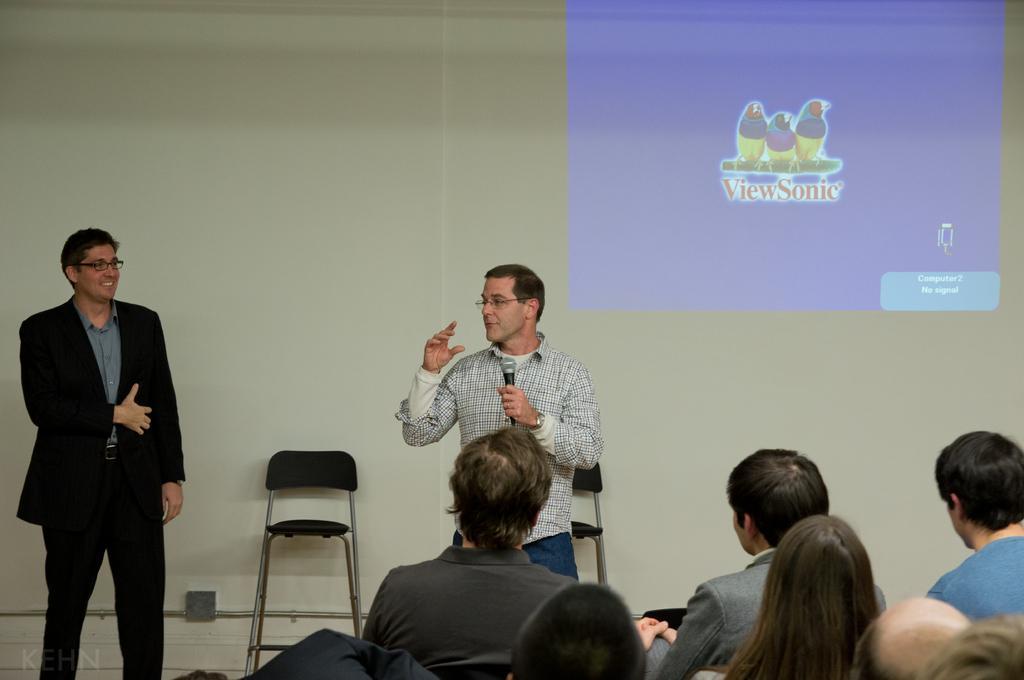Could you give a brief overview of what you see in this image? In a room there are lot of crowd sitting and chairs and listening to man speaking on microphone. Behind him there are few chairs and beside the chair there is another man standing in black blazer. And on the wall there is projector screen. 